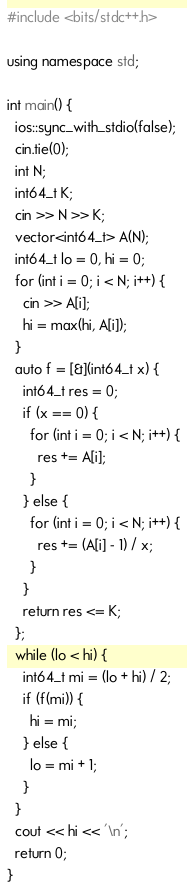<code> <loc_0><loc_0><loc_500><loc_500><_C++_>#include <bits/stdc++.h>

using namespace std;

int main() {
  ios::sync_with_stdio(false);
  cin.tie(0);
  int N;
  int64_t K;
  cin >> N >> K;
  vector<int64_t> A(N);
  int64_t lo = 0, hi = 0;
  for (int i = 0; i < N; i++) {
    cin >> A[i];
    hi = max(hi, A[i]);
  }
  auto f = [&](int64_t x) {
    int64_t res = 0;
    if (x == 0) {
      for (int i = 0; i < N; i++) {
        res += A[i];
      }
    } else {
      for (int i = 0; i < N; i++) {
        res += (A[i] - 1) / x;
      }
    }
    return res <= K;
  };
  while (lo < hi) {
    int64_t mi = (lo + hi) / 2;
    if (f(mi)) {
      hi = mi;
    } else {
      lo = mi + 1;
    }
  }
  cout << hi << '\n';
  return 0;
}
</code> 